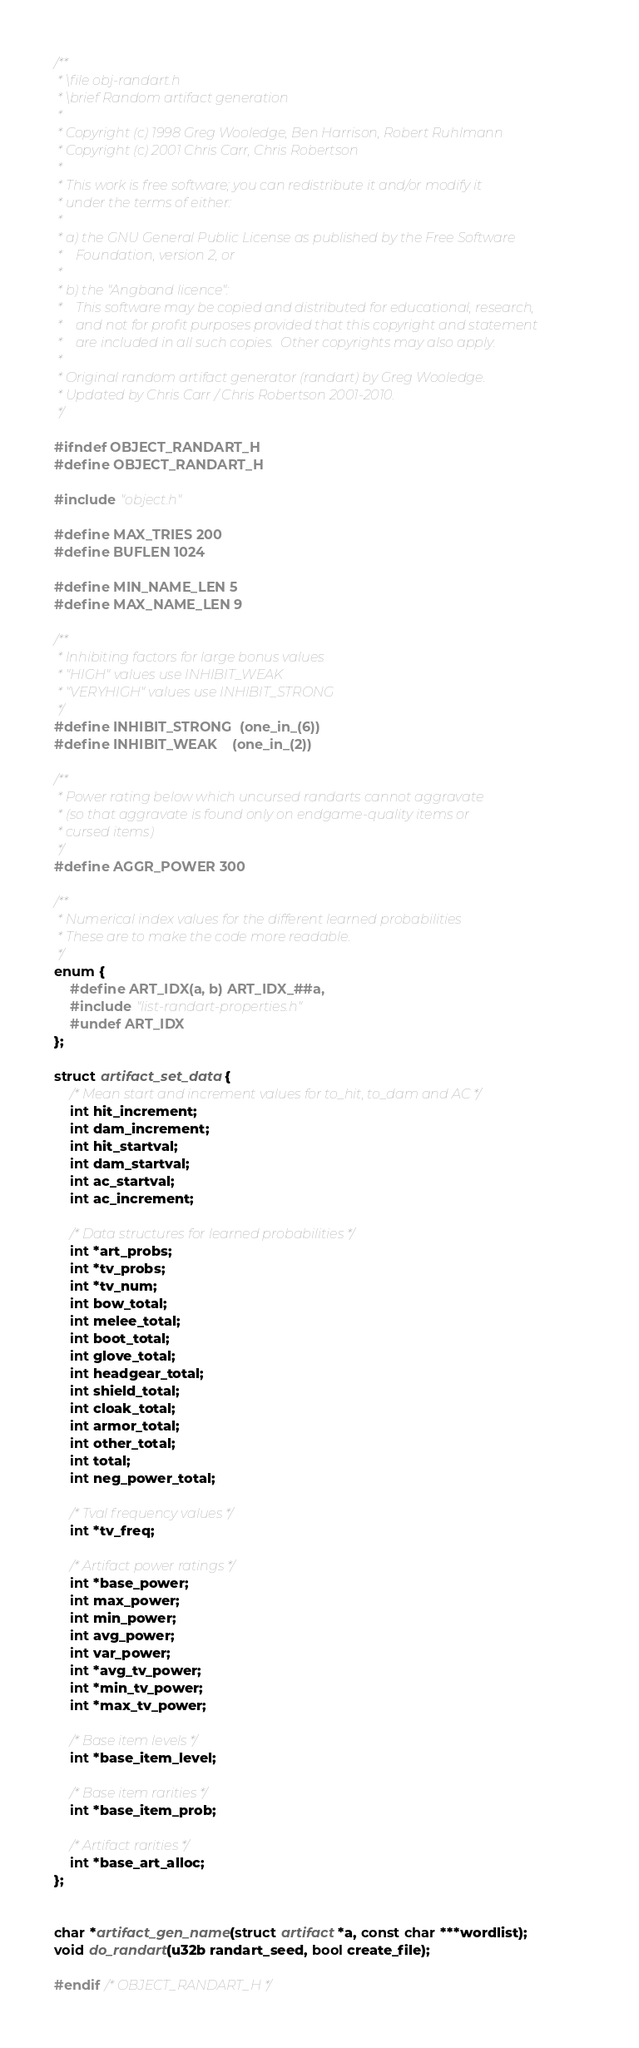Convert code to text. <code><loc_0><loc_0><loc_500><loc_500><_C_>/**
 * \file obj-randart.h
 * \brief Random artifact generation
 *
 * Copyright (c) 1998 Greg Wooledge, Ben Harrison, Robert Ruhlmann
 * Copyright (c) 2001 Chris Carr, Chris Robertson
 *
 * This work is free software; you can redistribute it and/or modify it
 * under the terms of either:
 *
 * a) the GNU General Public License as published by the Free Software
 *    Foundation, version 2, or
 *
 * b) the "Angband licence":
 *    This software may be copied and distributed for educational, research,
 *    and not for profit purposes provided that this copyright and statement
 *    are included in all such copies.  Other copyrights may also apply.
 *
 * Original random artifact generator (randart) by Greg Wooledge.
 * Updated by Chris Carr / Chris Robertson 2001-2010.
 */

#ifndef OBJECT_RANDART_H
#define OBJECT_RANDART_H

#include "object.h"

#define MAX_TRIES 200
#define BUFLEN 1024

#define MIN_NAME_LEN 5
#define MAX_NAME_LEN 9

/**
 * Inhibiting factors for large bonus values
 * "HIGH" values use INHIBIT_WEAK
 * "VERYHIGH" values use INHIBIT_STRONG
 */
#define INHIBIT_STRONG  (one_in_(6))
#define INHIBIT_WEAK    (one_in_(2))

/**
 * Power rating below which uncursed randarts cannot aggravate
 * (so that aggravate is found only on endgame-quality items or
 * cursed items)
 */
#define AGGR_POWER 300

/**
 * Numerical index values for the different learned probabilities
 * These are to make the code more readable.
 */
enum {
	#define ART_IDX(a, b) ART_IDX_##a,
	#include "list-randart-properties.h"
	#undef ART_IDX
};

struct artifact_set_data {
	/* Mean start and increment values for to_hit, to_dam and AC */
	int hit_increment;
	int dam_increment;
	int hit_startval;
	int dam_startval;
	int ac_startval;
	int ac_increment;

	/* Data structures for learned probabilities */
	int *art_probs;
	int *tv_probs;
	int *tv_num;
	int bow_total;
	int melee_total;
	int boot_total;
	int glove_total;
	int headgear_total;
	int shield_total;
	int cloak_total;
	int armor_total;
	int other_total;
	int total;
	int neg_power_total;

	/* Tval frequency values */
	int *tv_freq;

	/* Artifact power ratings */
	int *base_power;
	int max_power;
	int min_power;
	int avg_power;
	int var_power;
	int *avg_tv_power;
	int *min_tv_power;
	int *max_tv_power;

	/* Base item levels */
	int *base_item_level;

	/* Base item rarities */
	int *base_item_prob;

	/* Artifact rarities */
	int *base_art_alloc;
};


char *artifact_gen_name(struct artifact *a, const char ***wordlist);
void do_randart(u32b randart_seed, bool create_file);

#endif /* OBJECT_RANDART_H */
</code> 